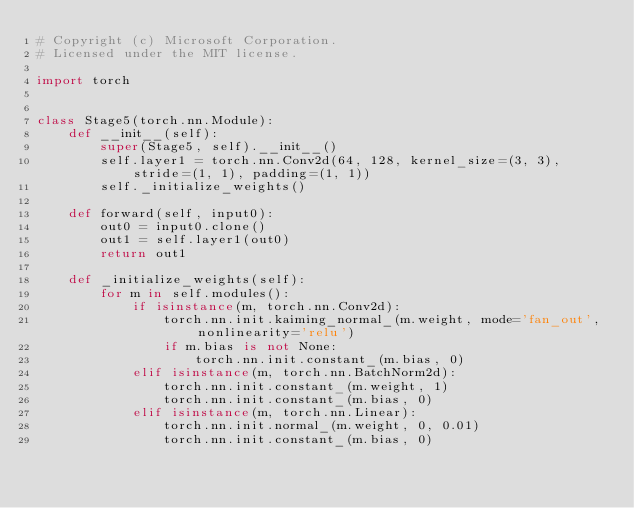Convert code to text. <code><loc_0><loc_0><loc_500><loc_500><_Python_># Copyright (c) Microsoft Corporation.
# Licensed under the MIT license.

import torch


class Stage5(torch.nn.Module):
    def __init__(self):
        super(Stage5, self).__init__()
        self.layer1 = torch.nn.Conv2d(64, 128, kernel_size=(3, 3), stride=(1, 1), padding=(1, 1))
        self._initialize_weights()

    def forward(self, input0):
        out0 = input0.clone()
        out1 = self.layer1(out0)
        return out1

    def _initialize_weights(self):
        for m in self.modules():
            if isinstance(m, torch.nn.Conv2d):
                torch.nn.init.kaiming_normal_(m.weight, mode='fan_out', nonlinearity='relu')
                if m.bias is not None:
                    torch.nn.init.constant_(m.bias, 0)
            elif isinstance(m, torch.nn.BatchNorm2d):
                torch.nn.init.constant_(m.weight, 1)
                torch.nn.init.constant_(m.bias, 0)
            elif isinstance(m, torch.nn.Linear):
                torch.nn.init.normal_(m.weight, 0, 0.01)
                torch.nn.init.constant_(m.bias, 0)
</code> 